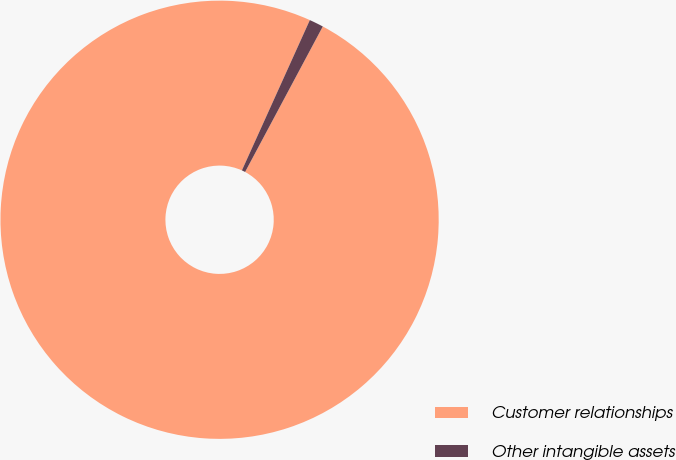Convert chart. <chart><loc_0><loc_0><loc_500><loc_500><pie_chart><fcel>Customer relationships<fcel>Other intangible assets<nl><fcel>98.95%<fcel>1.05%<nl></chart> 